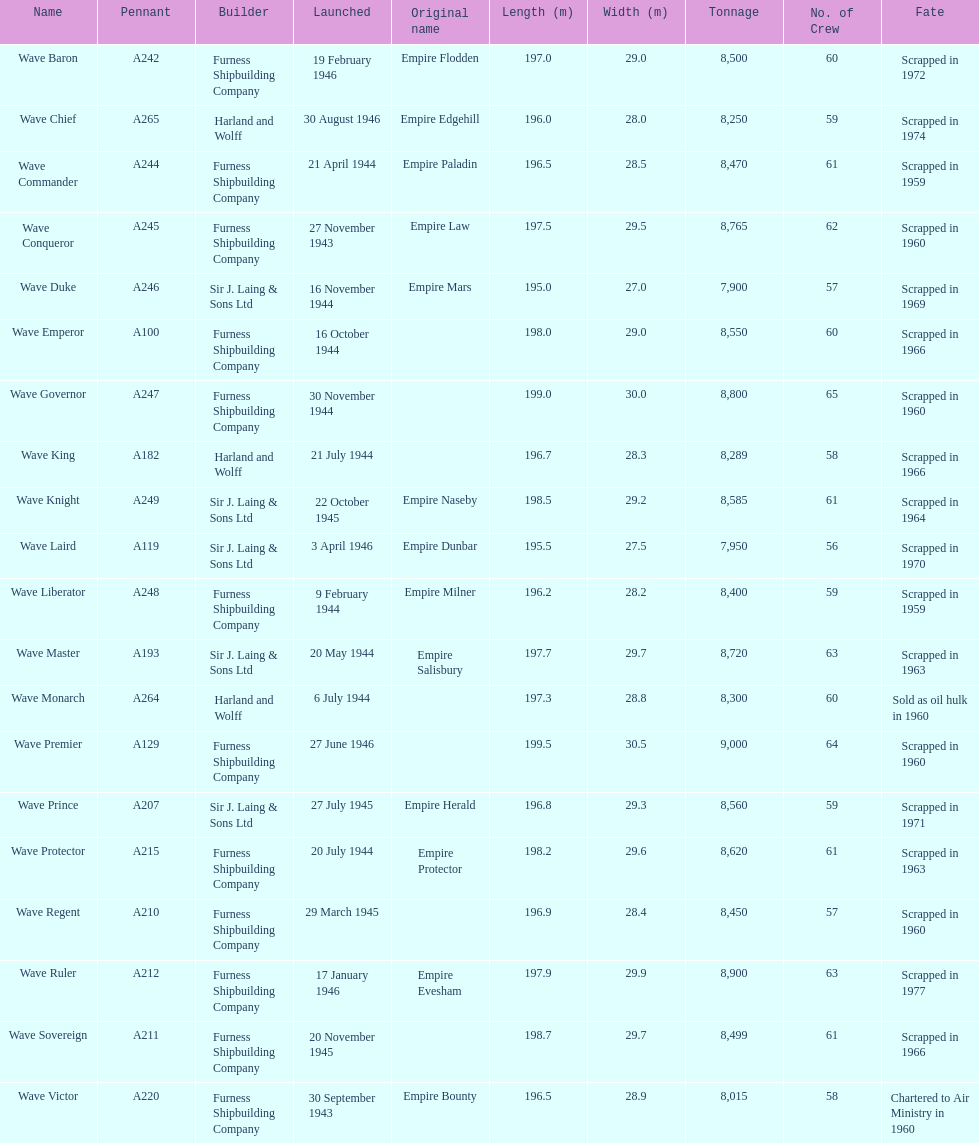Which other ship was launched in the same year as the wave victor? Wave Conqueror. 